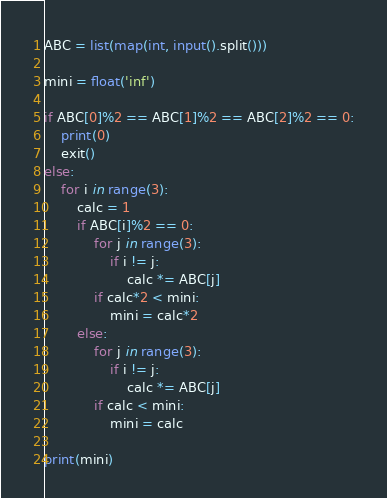Convert code to text. <code><loc_0><loc_0><loc_500><loc_500><_Python_>ABC = list(map(int, input().split()))

mini = float('inf')

if ABC[0]%2 == ABC[1]%2 == ABC[2]%2 == 0:
    print(0)
    exit()
else:
    for i in range(3):
        calc = 1
        if ABC[i]%2 == 0:
            for j in range(3):
                if i != j:
                    calc *= ABC[j]
            if calc*2 < mini:
                mini = calc*2
        else:
            for j in range(3):
                if i != j:
                    calc *= ABC[j]
            if calc < mini:
                mini = calc

print(mini)</code> 